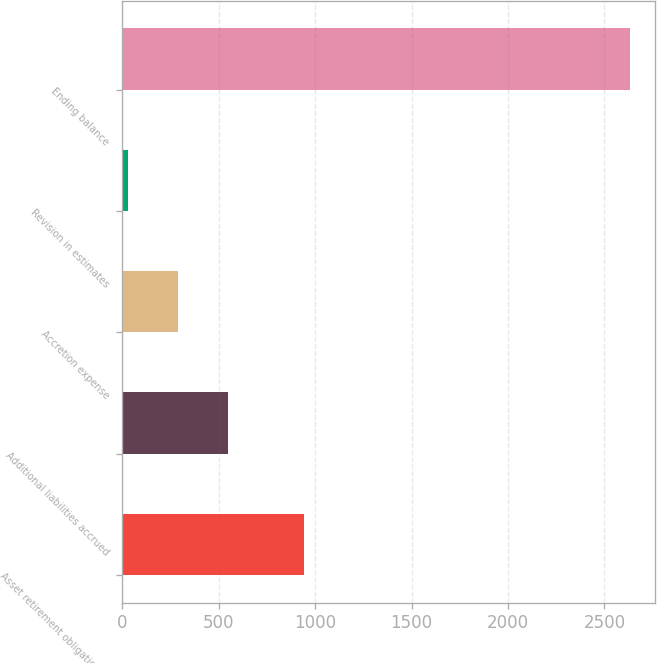Convert chart to OTSL. <chart><loc_0><loc_0><loc_500><loc_500><bar_chart><fcel>Asset retirement obligation at<fcel>Additional liabilities accrued<fcel>Accretion expense<fcel>Revision in estimates<fcel>Ending balance<nl><fcel>942<fcel>548<fcel>287.5<fcel>27<fcel>2632<nl></chart> 